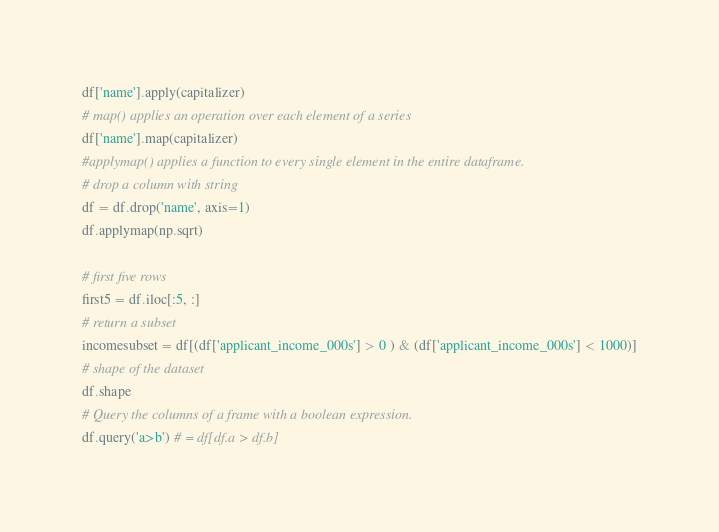<code> <loc_0><loc_0><loc_500><loc_500><_Python_>df['name'].apply(capitalizer)
# map() applies an operation over each element of a series
df['name'].map(capitalizer)
#applymap() applies a function to every single element in the entire dataframe.
# drop a column with string
df = df.drop('name', axis=1)
df.applymap(np.sqrt)

# first five rows
first5 = df.iloc[:5, :]
# return a subset
incomesubset = df[(df['applicant_income_000s'] > 0 ) & (df['applicant_income_000s'] < 1000)]
# shape of the dataset
df.shape
# Query the columns of a frame with a boolean expression.
df.query('a>b') # = df[df.a > df.b]























</code> 